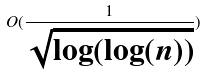<formula> <loc_0><loc_0><loc_500><loc_500>O ( \frac { 1 } { \sqrt { \log ( \log ( n ) ) } } )</formula> 